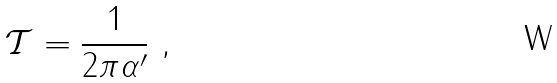<formula> <loc_0><loc_0><loc_500><loc_500>\mathcal { T } = \frac { 1 } { 2 \pi \alpha ^ { \prime } } \ ,</formula> 